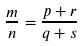<formula> <loc_0><loc_0><loc_500><loc_500>\frac { m } { n } = \frac { p + r } { q + s }</formula> 